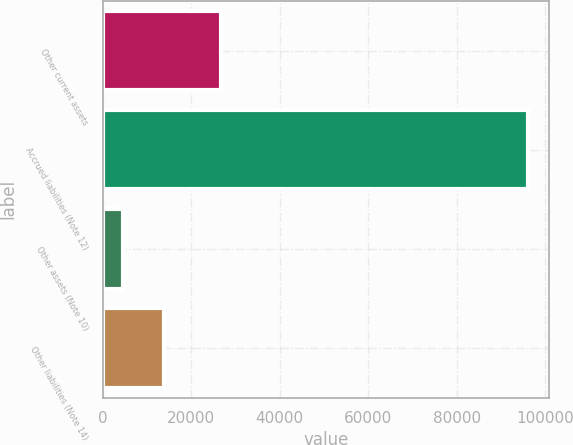Convert chart to OTSL. <chart><loc_0><loc_0><loc_500><loc_500><bar_chart><fcel>Other current assets<fcel>Accrued liabilities (Note 12)<fcel>Other assets (Note 10)<fcel>Other liabilities (Note 14)<nl><fcel>26741<fcel>96087<fcel>4659<fcel>13801.8<nl></chart> 